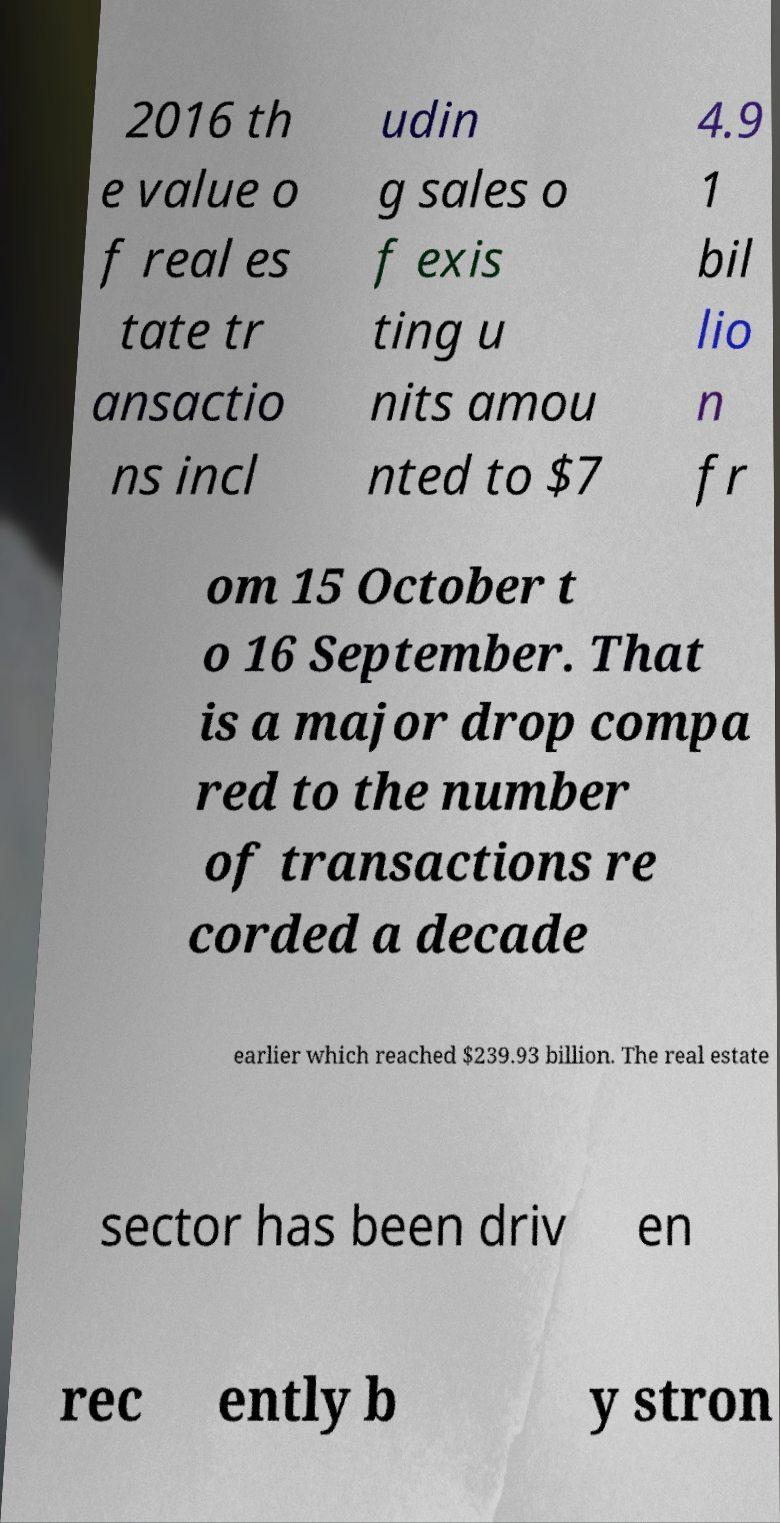I need the written content from this picture converted into text. Can you do that? 2016 th e value o f real es tate tr ansactio ns incl udin g sales o f exis ting u nits amou nted to $7 4.9 1 bil lio n fr om 15 October t o 16 September. That is a major drop compa red to the number of transactions re corded a decade earlier which reached $239.93 billion. The real estate sector has been driv en rec ently b y stron 